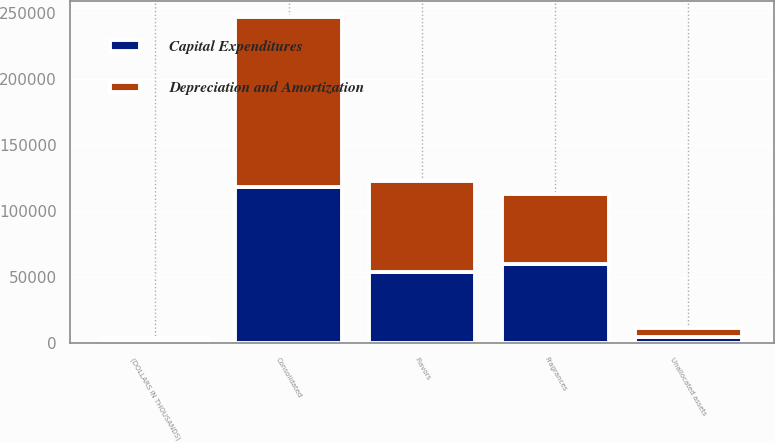Convert chart. <chart><loc_0><loc_0><loc_500><loc_500><stacked_bar_chart><ecel><fcel>(DOLLARS IN THOUSANDS)<fcel>Flavors<fcel>Fragrances<fcel>Unallocated assets<fcel>Consolidated<nl><fcel>Depreciation and Amortization<fcel>2017<fcel>68937<fcel>53089<fcel>6947<fcel>128973<nl><fcel>Capital Expenditures<fcel>2017<fcel>53534<fcel>59951<fcel>4482<fcel>117967<nl></chart> 